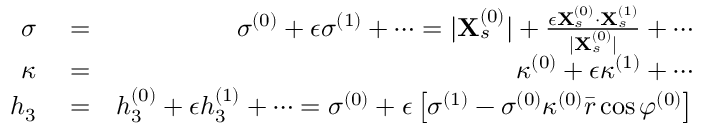Convert formula to latex. <formula><loc_0><loc_0><loc_500><loc_500>\begin{array} { r l r } { \sigma } & = } & { \sigma ^ { ( 0 ) } + \epsilon \sigma ^ { ( 1 ) } + \cdots = | X _ { s } ^ { ( 0 ) } | + \frac { \epsilon X _ { s } ^ { ( 0 ) } \cdot X _ { s } ^ { ( 1 ) } } { | X _ { s } ^ { ( 0 ) } | } + \cdots } \\ { \kappa } & = } & { \kappa ^ { ( 0 ) } + \epsilon \kappa ^ { ( 1 ) } + \cdots } \\ { h _ { 3 } } & = } & { h _ { 3 } ^ { ( 0 ) } + \epsilon h _ { 3 } ^ { ( 1 ) } + \cdots = \sigma ^ { ( 0 ) } + \epsilon \left [ \sigma ^ { ( 1 ) } - \sigma ^ { ( 0 ) } \kappa ^ { ( 0 ) } \bar { r } \cos \varphi ^ { ( 0 ) } \right ] } \end{array}</formula> 